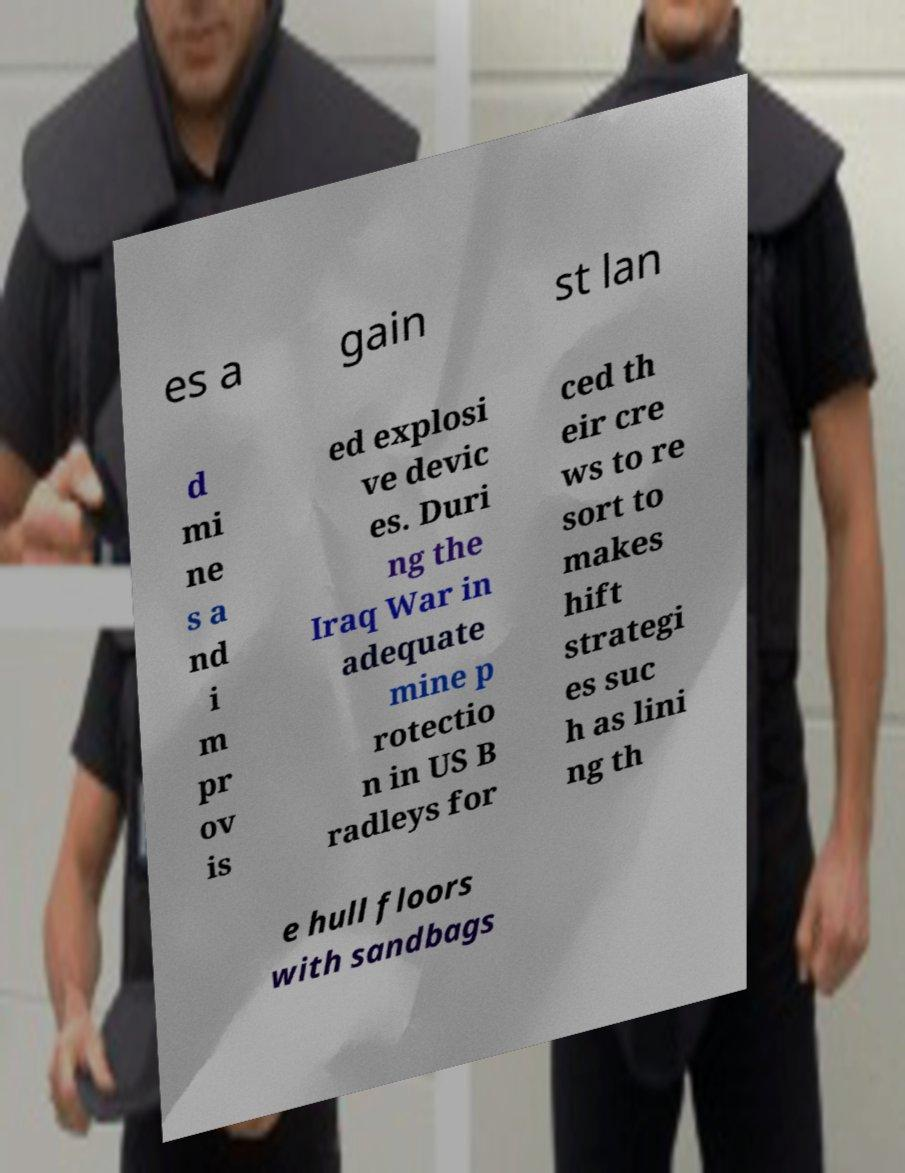There's text embedded in this image that I need extracted. Can you transcribe it verbatim? es a gain st lan d mi ne s a nd i m pr ov is ed explosi ve devic es. Duri ng the Iraq War in adequate mine p rotectio n in US B radleys for ced th eir cre ws to re sort to makes hift strategi es suc h as lini ng th e hull floors with sandbags 